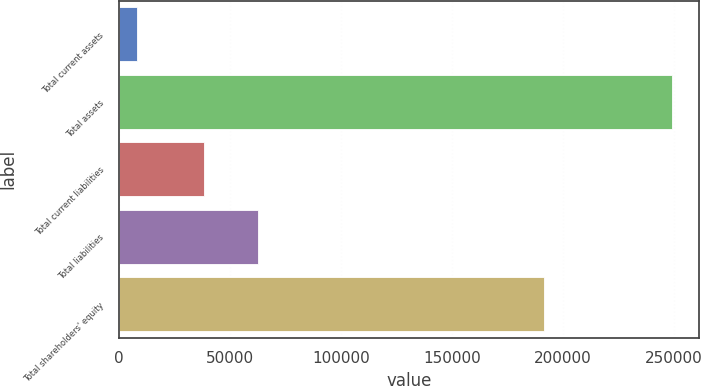Convert chart. <chart><loc_0><loc_0><loc_500><loc_500><bar_chart><fcel>Total current assets<fcel>Total assets<fcel>Total current liabilities<fcel>Total liabilities<fcel>Total shareholders' equity<nl><fcel>7833<fcel>249014<fcel>38266<fcel>62384.1<fcel>191508<nl></chart> 